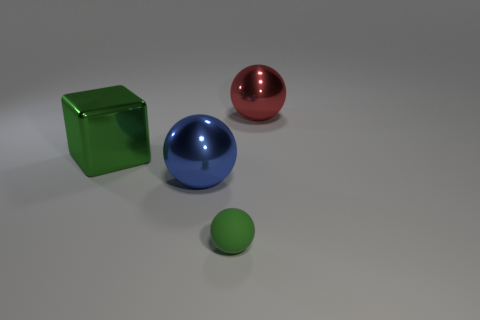Subtract all blue balls. How many balls are left? 2 Subtract 2 spheres. How many spheres are left? 1 Subtract all red spheres. Subtract all blue cubes. How many spheres are left? 2 Subtract all cyan cylinders. How many red spheres are left? 1 Subtract all big rubber things. Subtract all big shiny balls. How many objects are left? 2 Add 4 small matte things. How many small matte things are left? 5 Add 3 big green cubes. How many big green cubes exist? 4 Add 3 big cylinders. How many objects exist? 7 Subtract all red spheres. How many spheres are left? 2 Subtract 0 brown spheres. How many objects are left? 4 